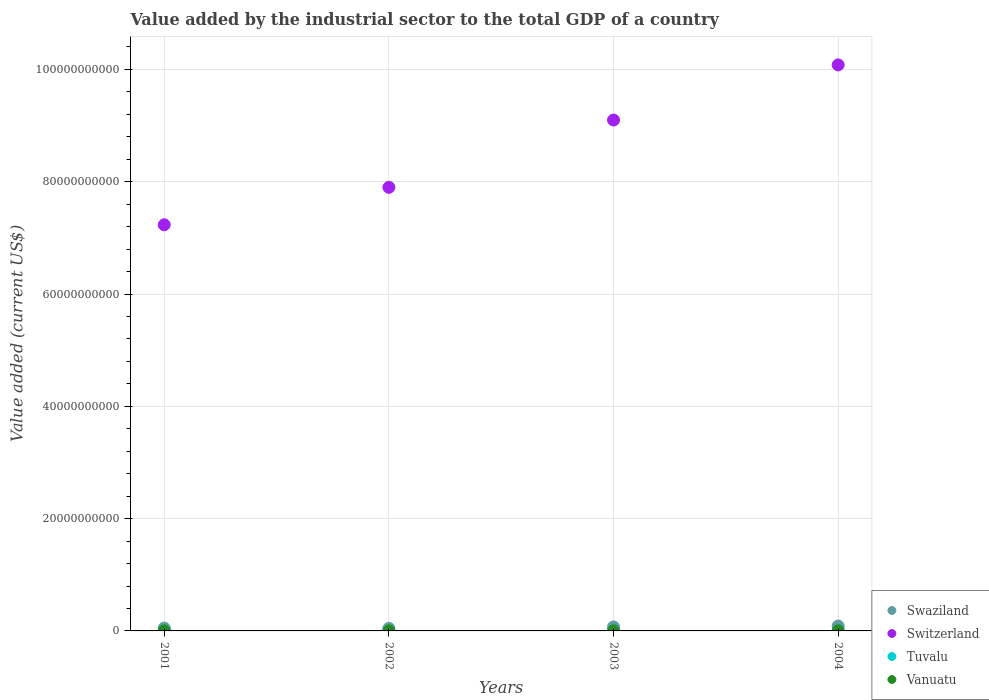What is the value added by the industrial sector to the total GDP in Vanuatu in 2002?
Your answer should be very brief. 2.35e+07. Across all years, what is the maximum value added by the industrial sector to the total GDP in Vanuatu?
Make the answer very short. 2.77e+07. Across all years, what is the minimum value added by the industrial sector to the total GDP in Swaziland?
Ensure brevity in your answer.  4.52e+08. In which year was the value added by the industrial sector to the total GDP in Switzerland maximum?
Your answer should be very brief. 2004. What is the total value added by the industrial sector to the total GDP in Tuvalu in the graph?
Your answer should be very brief. 6.18e+06. What is the difference between the value added by the industrial sector to the total GDP in Vanuatu in 2001 and that in 2003?
Keep it short and to the point. -2.43e+06. What is the difference between the value added by the industrial sector to the total GDP in Swaziland in 2002 and the value added by the industrial sector to the total GDP in Vanuatu in 2001?
Offer a terse response. 4.28e+08. What is the average value added by the industrial sector to the total GDP in Switzerland per year?
Offer a very short reply. 8.58e+1. In the year 2003, what is the difference between the value added by the industrial sector to the total GDP in Switzerland and value added by the industrial sector to the total GDP in Vanuatu?
Your answer should be compact. 9.10e+1. In how many years, is the value added by the industrial sector to the total GDP in Switzerland greater than 36000000000 US$?
Offer a very short reply. 4. What is the ratio of the value added by the industrial sector to the total GDP in Switzerland in 2001 to that in 2004?
Make the answer very short. 0.72. Is the value added by the industrial sector to the total GDP in Tuvalu in 2001 less than that in 2004?
Your answer should be compact. Yes. What is the difference between the highest and the second highest value added by the industrial sector to the total GDP in Switzerland?
Give a very brief answer. 9.82e+09. What is the difference between the highest and the lowest value added by the industrial sector to the total GDP in Tuvalu?
Give a very brief answer. 1.02e+06. In how many years, is the value added by the industrial sector to the total GDP in Vanuatu greater than the average value added by the industrial sector to the total GDP in Vanuatu taken over all years?
Ensure brevity in your answer.  2. Is the sum of the value added by the industrial sector to the total GDP in Swaziland in 2002 and 2003 greater than the maximum value added by the industrial sector to the total GDP in Vanuatu across all years?
Keep it short and to the point. Yes. Is it the case that in every year, the sum of the value added by the industrial sector to the total GDP in Swaziland and value added by the industrial sector to the total GDP in Switzerland  is greater than the sum of value added by the industrial sector to the total GDP in Tuvalu and value added by the industrial sector to the total GDP in Vanuatu?
Provide a succinct answer. Yes. Is it the case that in every year, the sum of the value added by the industrial sector to the total GDP in Swaziland and value added by the industrial sector to the total GDP in Switzerland  is greater than the value added by the industrial sector to the total GDP in Vanuatu?
Your answer should be very brief. Yes. Is the value added by the industrial sector to the total GDP in Tuvalu strictly less than the value added by the industrial sector to the total GDP in Switzerland over the years?
Your answer should be very brief. Yes. How many years are there in the graph?
Your response must be concise. 4. Are the values on the major ticks of Y-axis written in scientific E-notation?
Offer a very short reply. No. Does the graph contain grids?
Make the answer very short. Yes. Where does the legend appear in the graph?
Your response must be concise. Bottom right. How many legend labels are there?
Provide a succinct answer. 4. How are the legend labels stacked?
Your answer should be very brief. Vertical. What is the title of the graph?
Give a very brief answer. Value added by the industrial sector to the total GDP of a country. Does "Benin" appear as one of the legend labels in the graph?
Give a very brief answer. No. What is the label or title of the Y-axis?
Your answer should be very brief. Value added (current US$). What is the Value added (current US$) of Swaziland in 2001?
Make the answer very short. 5.04e+08. What is the Value added (current US$) of Switzerland in 2001?
Offer a very short reply. 7.23e+1. What is the Value added (current US$) of Tuvalu in 2001?
Provide a short and direct response. 1.04e+06. What is the Value added (current US$) of Vanuatu in 2001?
Provide a short and direct response. 2.33e+07. What is the Value added (current US$) in Swaziland in 2002?
Provide a succinct answer. 4.52e+08. What is the Value added (current US$) in Switzerland in 2002?
Your answer should be compact. 7.90e+1. What is the Value added (current US$) of Tuvalu in 2002?
Keep it short and to the point. 1.24e+06. What is the Value added (current US$) in Vanuatu in 2002?
Make the answer very short. 2.35e+07. What is the Value added (current US$) of Swaziland in 2003?
Offer a terse response. 7.11e+08. What is the Value added (current US$) of Switzerland in 2003?
Give a very brief answer. 9.10e+1. What is the Value added (current US$) in Tuvalu in 2003?
Offer a terse response. 1.86e+06. What is the Value added (current US$) of Vanuatu in 2003?
Offer a very short reply. 2.58e+07. What is the Value added (current US$) in Swaziland in 2004?
Provide a short and direct response. 8.76e+08. What is the Value added (current US$) of Switzerland in 2004?
Your answer should be very brief. 1.01e+11. What is the Value added (current US$) in Tuvalu in 2004?
Provide a succinct answer. 2.05e+06. What is the Value added (current US$) of Vanuatu in 2004?
Make the answer very short. 2.77e+07. Across all years, what is the maximum Value added (current US$) of Swaziland?
Your answer should be compact. 8.76e+08. Across all years, what is the maximum Value added (current US$) of Switzerland?
Provide a short and direct response. 1.01e+11. Across all years, what is the maximum Value added (current US$) of Tuvalu?
Make the answer very short. 2.05e+06. Across all years, what is the maximum Value added (current US$) in Vanuatu?
Give a very brief answer. 2.77e+07. Across all years, what is the minimum Value added (current US$) in Swaziland?
Provide a succinct answer. 4.52e+08. Across all years, what is the minimum Value added (current US$) of Switzerland?
Your answer should be very brief. 7.23e+1. Across all years, what is the minimum Value added (current US$) of Tuvalu?
Make the answer very short. 1.04e+06. Across all years, what is the minimum Value added (current US$) of Vanuatu?
Make the answer very short. 2.33e+07. What is the total Value added (current US$) of Swaziland in the graph?
Provide a succinct answer. 2.54e+09. What is the total Value added (current US$) in Switzerland in the graph?
Provide a short and direct response. 3.43e+11. What is the total Value added (current US$) in Tuvalu in the graph?
Your answer should be compact. 6.18e+06. What is the total Value added (current US$) of Vanuatu in the graph?
Your answer should be very brief. 1.00e+08. What is the difference between the Value added (current US$) of Swaziland in 2001 and that in 2002?
Keep it short and to the point. 5.29e+07. What is the difference between the Value added (current US$) of Switzerland in 2001 and that in 2002?
Provide a succinct answer. -6.67e+09. What is the difference between the Value added (current US$) in Tuvalu in 2001 and that in 2002?
Offer a terse response. -2.02e+05. What is the difference between the Value added (current US$) of Vanuatu in 2001 and that in 2002?
Provide a short and direct response. -1.70e+05. What is the difference between the Value added (current US$) of Swaziland in 2001 and that in 2003?
Your answer should be very brief. -2.06e+08. What is the difference between the Value added (current US$) of Switzerland in 2001 and that in 2003?
Give a very brief answer. -1.87e+1. What is the difference between the Value added (current US$) of Tuvalu in 2001 and that in 2003?
Keep it short and to the point. -8.21e+05. What is the difference between the Value added (current US$) of Vanuatu in 2001 and that in 2003?
Offer a very short reply. -2.43e+06. What is the difference between the Value added (current US$) of Swaziland in 2001 and that in 2004?
Your answer should be compact. -3.71e+08. What is the difference between the Value added (current US$) of Switzerland in 2001 and that in 2004?
Ensure brevity in your answer.  -2.85e+1. What is the difference between the Value added (current US$) of Tuvalu in 2001 and that in 2004?
Ensure brevity in your answer.  -1.02e+06. What is the difference between the Value added (current US$) of Vanuatu in 2001 and that in 2004?
Provide a short and direct response. -4.39e+06. What is the difference between the Value added (current US$) in Swaziland in 2002 and that in 2003?
Your answer should be compact. -2.59e+08. What is the difference between the Value added (current US$) of Switzerland in 2002 and that in 2003?
Give a very brief answer. -1.20e+1. What is the difference between the Value added (current US$) in Tuvalu in 2002 and that in 2003?
Offer a very short reply. -6.18e+05. What is the difference between the Value added (current US$) of Vanuatu in 2002 and that in 2003?
Make the answer very short. -2.26e+06. What is the difference between the Value added (current US$) of Swaziland in 2002 and that in 2004?
Your answer should be very brief. -4.24e+08. What is the difference between the Value added (current US$) of Switzerland in 2002 and that in 2004?
Offer a very short reply. -2.18e+1. What is the difference between the Value added (current US$) in Tuvalu in 2002 and that in 2004?
Your response must be concise. -8.13e+05. What is the difference between the Value added (current US$) of Vanuatu in 2002 and that in 2004?
Your answer should be very brief. -4.22e+06. What is the difference between the Value added (current US$) in Swaziland in 2003 and that in 2004?
Keep it short and to the point. -1.65e+08. What is the difference between the Value added (current US$) of Switzerland in 2003 and that in 2004?
Provide a succinct answer. -9.82e+09. What is the difference between the Value added (current US$) of Tuvalu in 2003 and that in 2004?
Your answer should be compact. -1.95e+05. What is the difference between the Value added (current US$) of Vanuatu in 2003 and that in 2004?
Your answer should be compact. -1.97e+06. What is the difference between the Value added (current US$) of Swaziland in 2001 and the Value added (current US$) of Switzerland in 2002?
Keep it short and to the point. -7.85e+1. What is the difference between the Value added (current US$) of Swaziland in 2001 and the Value added (current US$) of Tuvalu in 2002?
Ensure brevity in your answer.  5.03e+08. What is the difference between the Value added (current US$) of Swaziland in 2001 and the Value added (current US$) of Vanuatu in 2002?
Give a very brief answer. 4.81e+08. What is the difference between the Value added (current US$) in Switzerland in 2001 and the Value added (current US$) in Tuvalu in 2002?
Provide a short and direct response. 7.23e+1. What is the difference between the Value added (current US$) of Switzerland in 2001 and the Value added (current US$) of Vanuatu in 2002?
Provide a succinct answer. 7.23e+1. What is the difference between the Value added (current US$) of Tuvalu in 2001 and the Value added (current US$) of Vanuatu in 2002?
Ensure brevity in your answer.  -2.25e+07. What is the difference between the Value added (current US$) of Swaziland in 2001 and the Value added (current US$) of Switzerland in 2003?
Offer a very short reply. -9.05e+1. What is the difference between the Value added (current US$) of Swaziland in 2001 and the Value added (current US$) of Tuvalu in 2003?
Your response must be concise. 5.03e+08. What is the difference between the Value added (current US$) of Swaziland in 2001 and the Value added (current US$) of Vanuatu in 2003?
Provide a short and direct response. 4.79e+08. What is the difference between the Value added (current US$) in Switzerland in 2001 and the Value added (current US$) in Tuvalu in 2003?
Keep it short and to the point. 7.23e+1. What is the difference between the Value added (current US$) in Switzerland in 2001 and the Value added (current US$) in Vanuatu in 2003?
Provide a succinct answer. 7.23e+1. What is the difference between the Value added (current US$) in Tuvalu in 2001 and the Value added (current US$) in Vanuatu in 2003?
Your answer should be compact. -2.47e+07. What is the difference between the Value added (current US$) of Swaziland in 2001 and the Value added (current US$) of Switzerland in 2004?
Your answer should be very brief. -1.00e+11. What is the difference between the Value added (current US$) in Swaziland in 2001 and the Value added (current US$) in Tuvalu in 2004?
Your answer should be very brief. 5.02e+08. What is the difference between the Value added (current US$) in Swaziland in 2001 and the Value added (current US$) in Vanuatu in 2004?
Provide a succinct answer. 4.77e+08. What is the difference between the Value added (current US$) of Switzerland in 2001 and the Value added (current US$) of Tuvalu in 2004?
Give a very brief answer. 7.23e+1. What is the difference between the Value added (current US$) in Switzerland in 2001 and the Value added (current US$) in Vanuatu in 2004?
Provide a short and direct response. 7.23e+1. What is the difference between the Value added (current US$) in Tuvalu in 2001 and the Value added (current US$) in Vanuatu in 2004?
Your answer should be compact. -2.67e+07. What is the difference between the Value added (current US$) of Swaziland in 2002 and the Value added (current US$) of Switzerland in 2003?
Make the answer very short. -9.05e+1. What is the difference between the Value added (current US$) of Swaziland in 2002 and the Value added (current US$) of Tuvalu in 2003?
Make the answer very short. 4.50e+08. What is the difference between the Value added (current US$) of Swaziland in 2002 and the Value added (current US$) of Vanuatu in 2003?
Make the answer very short. 4.26e+08. What is the difference between the Value added (current US$) of Switzerland in 2002 and the Value added (current US$) of Tuvalu in 2003?
Give a very brief answer. 7.90e+1. What is the difference between the Value added (current US$) of Switzerland in 2002 and the Value added (current US$) of Vanuatu in 2003?
Offer a terse response. 7.90e+1. What is the difference between the Value added (current US$) in Tuvalu in 2002 and the Value added (current US$) in Vanuatu in 2003?
Your answer should be very brief. -2.45e+07. What is the difference between the Value added (current US$) of Swaziland in 2002 and the Value added (current US$) of Switzerland in 2004?
Offer a terse response. -1.00e+11. What is the difference between the Value added (current US$) in Swaziland in 2002 and the Value added (current US$) in Tuvalu in 2004?
Your response must be concise. 4.50e+08. What is the difference between the Value added (current US$) of Swaziland in 2002 and the Value added (current US$) of Vanuatu in 2004?
Provide a short and direct response. 4.24e+08. What is the difference between the Value added (current US$) in Switzerland in 2002 and the Value added (current US$) in Tuvalu in 2004?
Offer a terse response. 7.90e+1. What is the difference between the Value added (current US$) of Switzerland in 2002 and the Value added (current US$) of Vanuatu in 2004?
Provide a short and direct response. 7.90e+1. What is the difference between the Value added (current US$) in Tuvalu in 2002 and the Value added (current US$) in Vanuatu in 2004?
Give a very brief answer. -2.65e+07. What is the difference between the Value added (current US$) in Swaziland in 2003 and the Value added (current US$) in Switzerland in 2004?
Your response must be concise. -1.00e+11. What is the difference between the Value added (current US$) in Swaziland in 2003 and the Value added (current US$) in Tuvalu in 2004?
Your response must be concise. 7.09e+08. What is the difference between the Value added (current US$) of Swaziland in 2003 and the Value added (current US$) of Vanuatu in 2004?
Give a very brief answer. 6.83e+08. What is the difference between the Value added (current US$) of Switzerland in 2003 and the Value added (current US$) of Tuvalu in 2004?
Keep it short and to the point. 9.10e+1. What is the difference between the Value added (current US$) in Switzerland in 2003 and the Value added (current US$) in Vanuatu in 2004?
Offer a terse response. 9.10e+1. What is the difference between the Value added (current US$) in Tuvalu in 2003 and the Value added (current US$) in Vanuatu in 2004?
Provide a short and direct response. -2.59e+07. What is the average Value added (current US$) of Swaziland per year?
Your response must be concise. 6.36e+08. What is the average Value added (current US$) of Switzerland per year?
Provide a succinct answer. 8.58e+1. What is the average Value added (current US$) in Tuvalu per year?
Provide a short and direct response. 1.55e+06. What is the average Value added (current US$) in Vanuatu per year?
Provide a succinct answer. 2.51e+07. In the year 2001, what is the difference between the Value added (current US$) of Swaziland and Value added (current US$) of Switzerland?
Provide a succinct answer. -7.18e+1. In the year 2001, what is the difference between the Value added (current US$) of Swaziland and Value added (current US$) of Tuvalu?
Provide a short and direct response. 5.03e+08. In the year 2001, what is the difference between the Value added (current US$) of Swaziland and Value added (current US$) of Vanuatu?
Offer a very short reply. 4.81e+08. In the year 2001, what is the difference between the Value added (current US$) in Switzerland and Value added (current US$) in Tuvalu?
Offer a very short reply. 7.23e+1. In the year 2001, what is the difference between the Value added (current US$) of Switzerland and Value added (current US$) of Vanuatu?
Your response must be concise. 7.23e+1. In the year 2001, what is the difference between the Value added (current US$) of Tuvalu and Value added (current US$) of Vanuatu?
Make the answer very short. -2.23e+07. In the year 2002, what is the difference between the Value added (current US$) in Swaziland and Value added (current US$) in Switzerland?
Make the answer very short. -7.86e+1. In the year 2002, what is the difference between the Value added (current US$) of Swaziland and Value added (current US$) of Tuvalu?
Offer a terse response. 4.50e+08. In the year 2002, what is the difference between the Value added (current US$) of Swaziland and Value added (current US$) of Vanuatu?
Provide a succinct answer. 4.28e+08. In the year 2002, what is the difference between the Value added (current US$) in Switzerland and Value added (current US$) in Tuvalu?
Ensure brevity in your answer.  7.90e+1. In the year 2002, what is the difference between the Value added (current US$) of Switzerland and Value added (current US$) of Vanuatu?
Your answer should be compact. 7.90e+1. In the year 2002, what is the difference between the Value added (current US$) of Tuvalu and Value added (current US$) of Vanuatu?
Keep it short and to the point. -2.23e+07. In the year 2003, what is the difference between the Value added (current US$) in Swaziland and Value added (current US$) in Switzerland?
Provide a short and direct response. -9.03e+1. In the year 2003, what is the difference between the Value added (current US$) of Swaziland and Value added (current US$) of Tuvalu?
Make the answer very short. 7.09e+08. In the year 2003, what is the difference between the Value added (current US$) in Swaziland and Value added (current US$) in Vanuatu?
Provide a succinct answer. 6.85e+08. In the year 2003, what is the difference between the Value added (current US$) in Switzerland and Value added (current US$) in Tuvalu?
Your answer should be compact. 9.10e+1. In the year 2003, what is the difference between the Value added (current US$) of Switzerland and Value added (current US$) of Vanuatu?
Keep it short and to the point. 9.10e+1. In the year 2003, what is the difference between the Value added (current US$) of Tuvalu and Value added (current US$) of Vanuatu?
Keep it short and to the point. -2.39e+07. In the year 2004, what is the difference between the Value added (current US$) in Swaziland and Value added (current US$) in Switzerland?
Keep it short and to the point. -9.99e+1. In the year 2004, what is the difference between the Value added (current US$) of Swaziland and Value added (current US$) of Tuvalu?
Your response must be concise. 8.74e+08. In the year 2004, what is the difference between the Value added (current US$) in Swaziland and Value added (current US$) in Vanuatu?
Your response must be concise. 8.48e+08. In the year 2004, what is the difference between the Value added (current US$) in Switzerland and Value added (current US$) in Tuvalu?
Your response must be concise. 1.01e+11. In the year 2004, what is the difference between the Value added (current US$) of Switzerland and Value added (current US$) of Vanuatu?
Your response must be concise. 1.01e+11. In the year 2004, what is the difference between the Value added (current US$) of Tuvalu and Value added (current US$) of Vanuatu?
Give a very brief answer. -2.57e+07. What is the ratio of the Value added (current US$) of Swaziland in 2001 to that in 2002?
Your answer should be compact. 1.12. What is the ratio of the Value added (current US$) of Switzerland in 2001 to that in 2002?
Give a very brief answer. 0.92. What is the ratio of the Value added (current US$) in Tuvalu in 2001 to that in 2002?
Offer a terse response. 0.84. What is the ratio of the Value added (current US$) of Vanuatu in 2001 to that in 2002?
Offer a terse response. 0.99. What is the ratio of the Value added (current US$) of Swaziland in 2001 to that in 2003?
Offer a terse response. 0.71. What is the ratio of the Value added (current US$) of Switzerland in 2001 to that in 2003?
Provide a short and direct response. 0.8. What is the ratio of the Value added (current US$) of Tuvalu in 2001 to that in 2003?
Make the answer very short. 0.56. What is the ratio of the Value added (current US$) in Vanuatu in 2001 to that in 2003?
Give a very brief answer. 0.91. What is the ratio of the Value added (current US$) of Swaziland in 2001 to that in 2004?
Offer a very short reply. 0.58. What is the ratio of the Value added (current US$) of Switzerland in 2001 to that in 2004?
Keep it short and to the point. 0.72. What is the ratio of the Value added (current US$) in Tuvalu in 2001 to that in 2004?
Give a very brief answer. 0.5. What is the ratio of the Value added (current US$) in Vanuatu in 2001 to that in 2004?
Your response must be concise. 0.84. What is the ratio of the Value added (current US$) in Swaziland in 2002 to that in 2003?
Ensure brevity in your answer.  0.64. What is the ratio of the Value added (current US$) of Switzerland in 2002 to that in 2003?
Make the answer very short. 0.87. What is the ratio of the Value added (current US$) in Tuvalu in 2002 to that in 2003?
Keep it short and to the point. 0.67. What is the ratio of the Value added (current US$) in Vanuatu in 2002 to that in 2003?
Your answer should be compact. 0.91. What is the ratio of the Value added (current US$) in Swaziland in 2002 to that in 2004?
Give a very brief answer. 0.52. What is the ratio of the Value added (current US$) in Switzerland in 2002 to that in 2004?
Offer a very short reply. 0.78. What is the ratio of the Value added (current US$) in Tuvalu in 2002 to that in 2004?
Provide a succinct answer. 0.6. What is the ratio of the Value added (current US$) of Vanuatu in 2002 to that in 2004?
Provide a succinct answer. 0.85. What is the ratio of the Value added (current US$) of Swaziland in 2003 to that in 2004?
Keep it short and to the point. 0.81. What is the ratio of the Value added (current US$) of Switzerland in 2003 to that in 2004?
Offer a terse response. 0.9. What is the ratio of the Value added (current US$) in Tuvalu in 2003 to that in 2004?
Your answer should be compact. 0.91. What is the ratio of the Value added (current US$) in Vanuatu in 2003 to that in 2004?
Your answer should be compact. 0.93. What is the difference between the highest and the second highest Value added (current US$) of Swaziland?
Provide a succinct answer. 1.65e+08. What is the difference between the highest and the second highest Value added (current US$) of Switzerland?
Your answer should be compact. 9.82e+09. What is the difference between the highest and the second highest Value added (current US$) of Tuvalu?
Make the answer very short. 1.95e+05. What is the difference between the highest and the second highest Value added (current US$) of Vanuatu?
Your response must be concise. 1.97e+06. What is the difference between the highest and the lowest Value added (current US$) in Swaziland?
Your response must be concise. 4.24e+08. What is the difference between the highest and the lowest Value added (current US$) in Switzerland?
Give a very brief answer. 2.85e+1. What is the difference between the highest and the lowest Value added (current US$) in Tuvalu?
Your answer should be very brief. 1.02e+06. What is the difference between the highest and the lowest Value added (current US$) in Vanuatu?
Provide a short and direct response. 4.39e+06. 